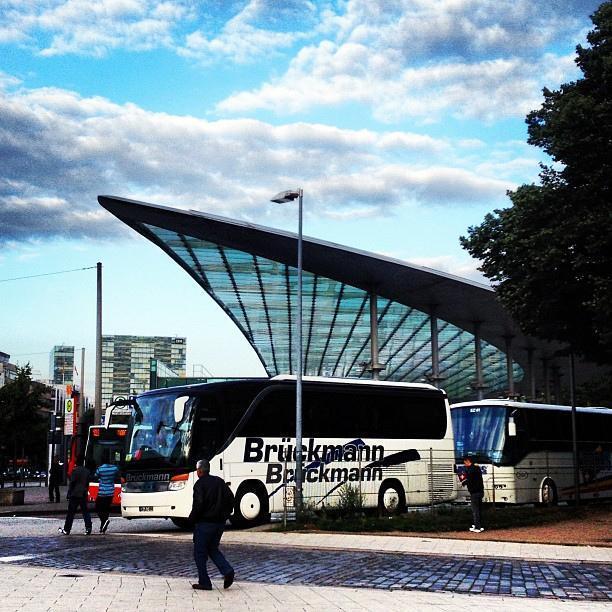How many buses can you see?
Give a very brief answer. 2. 